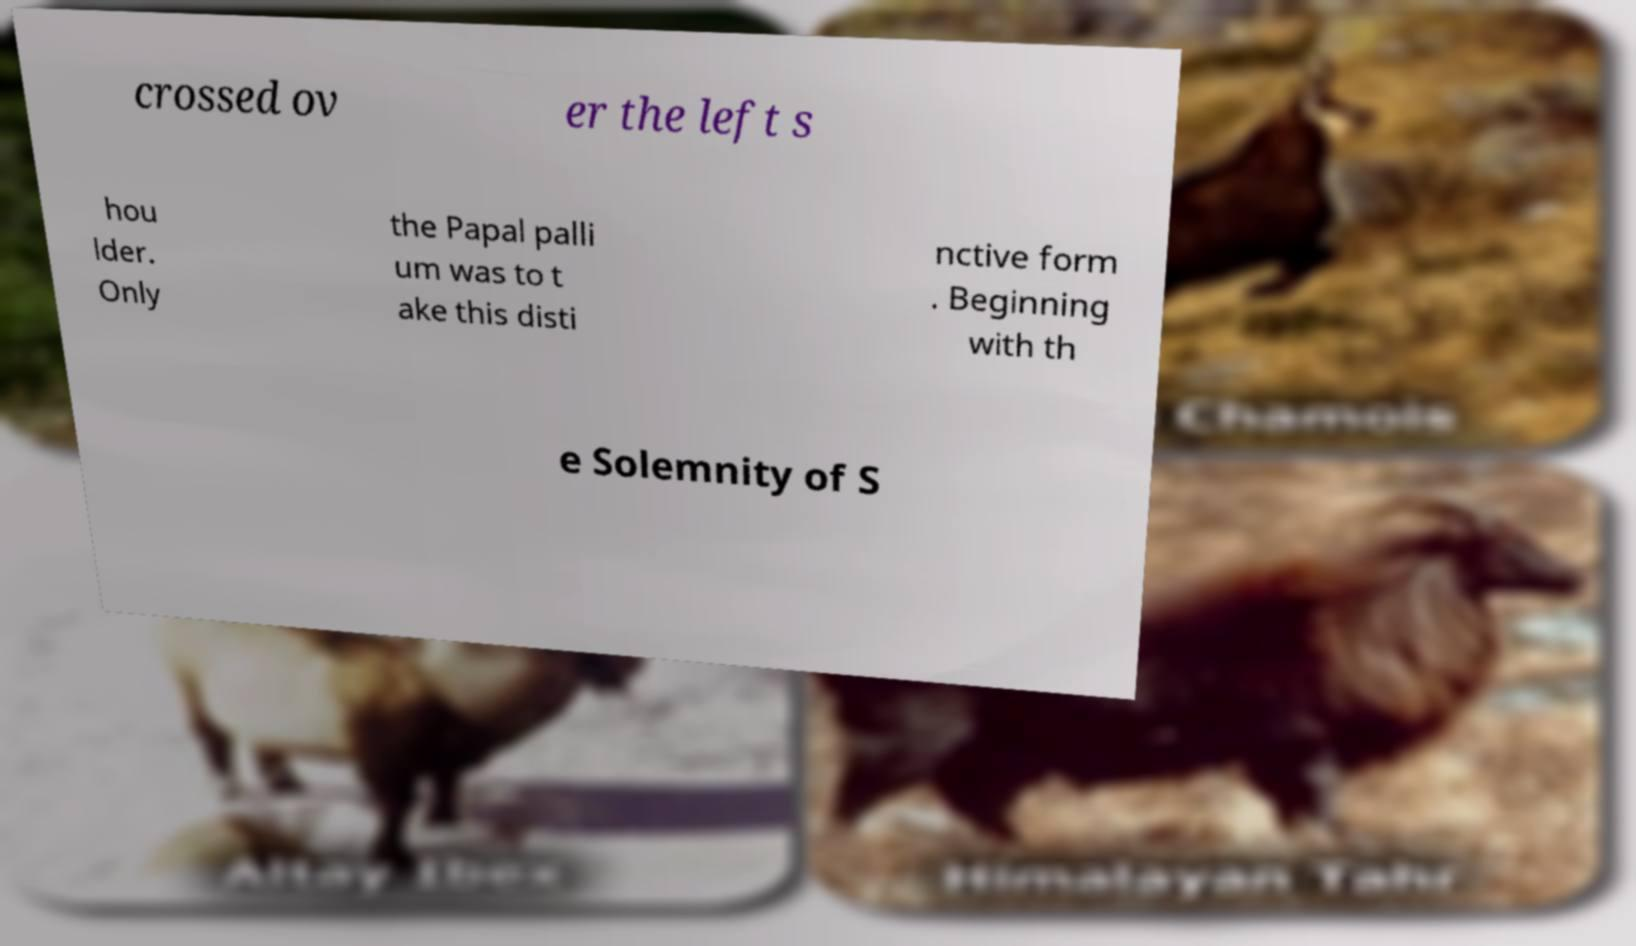For documentation purposes, I need the text within this image transcribed. Could you provide that? crossed ov er the left s hou lder. Only the Papal palli um was to t ake this disti nctive form . Beginning with th e Solemnity of S 